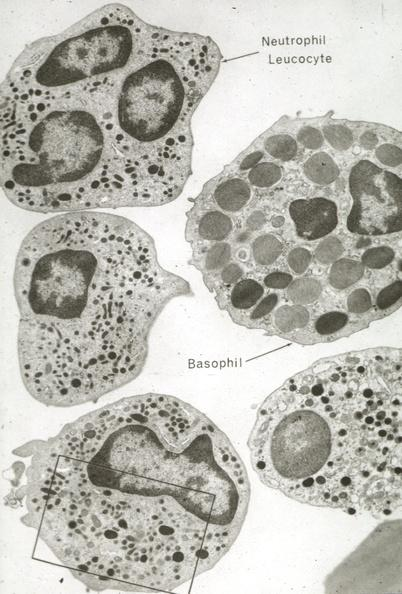what is present?
Answer the question using a single word or phrase. Hematologic 